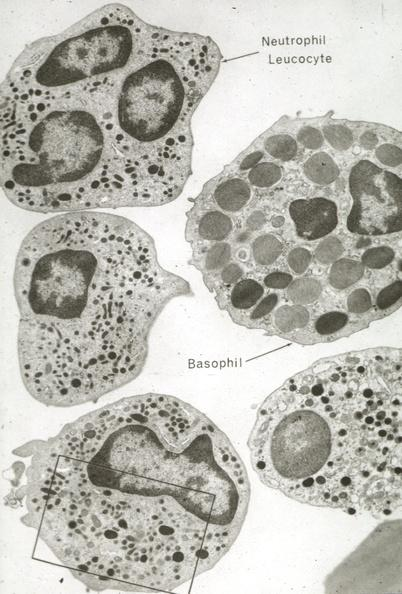what is present?
Answer the question using a single word or phrase. Hematologic 